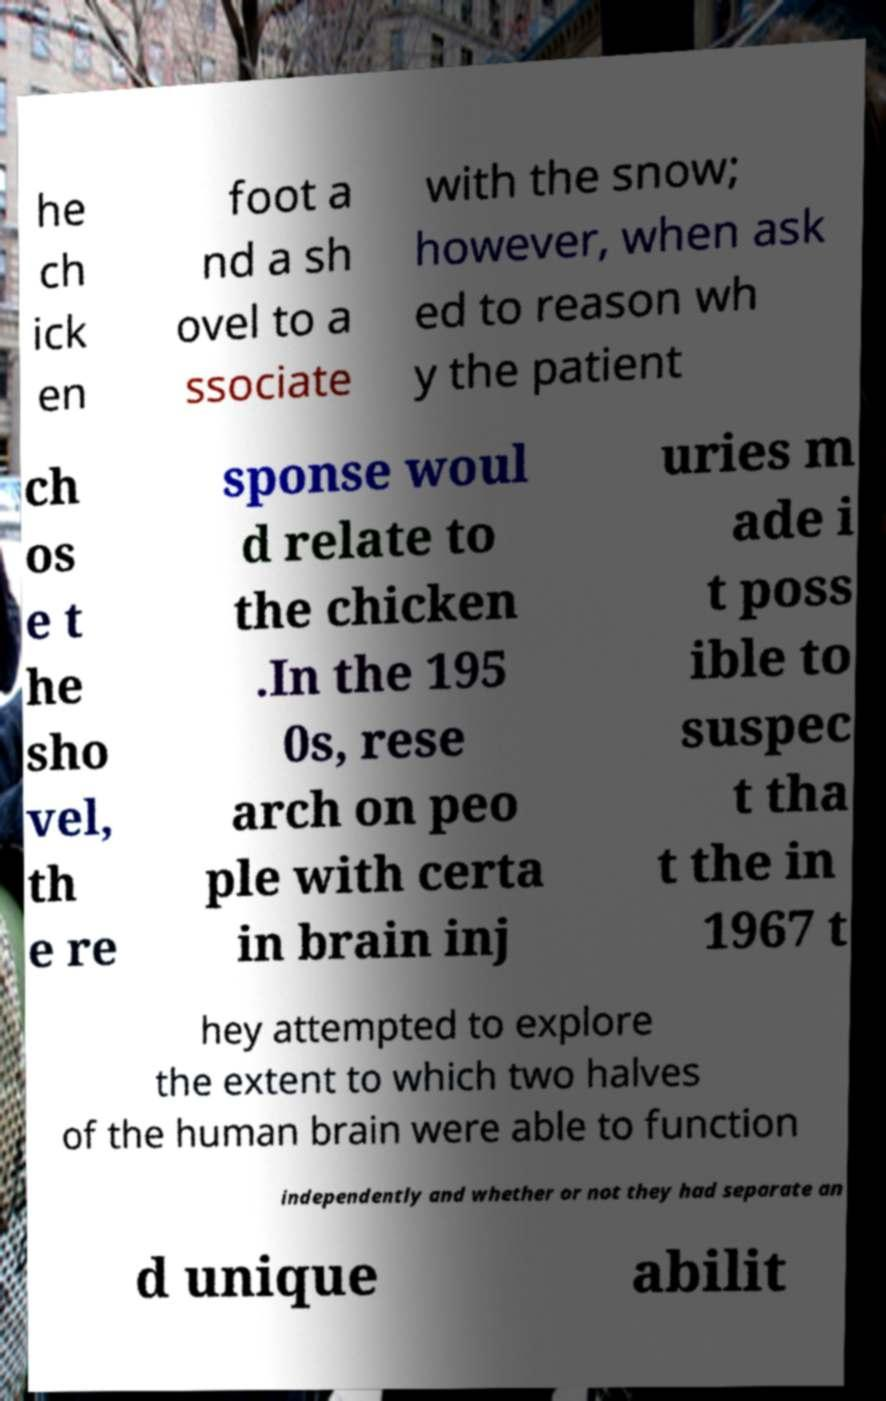Please read and relay the text visible in this image. What does it say? he ch ick en foot a nd a sh ovel to a ssociate with the snow; however, when ask ed to reason wh y the patient ch os e t he sho vel, th e re sponse woul d relate to the chicken .In the 195 0s, rese arch on peo ple with certa in brain inj uries m ade i t poss ible to suspec t tha t the in 1967 t hey attempted to explore the extent to which two halves of the human brain were able to function independently and whether or not they had separate an d unique abilit 